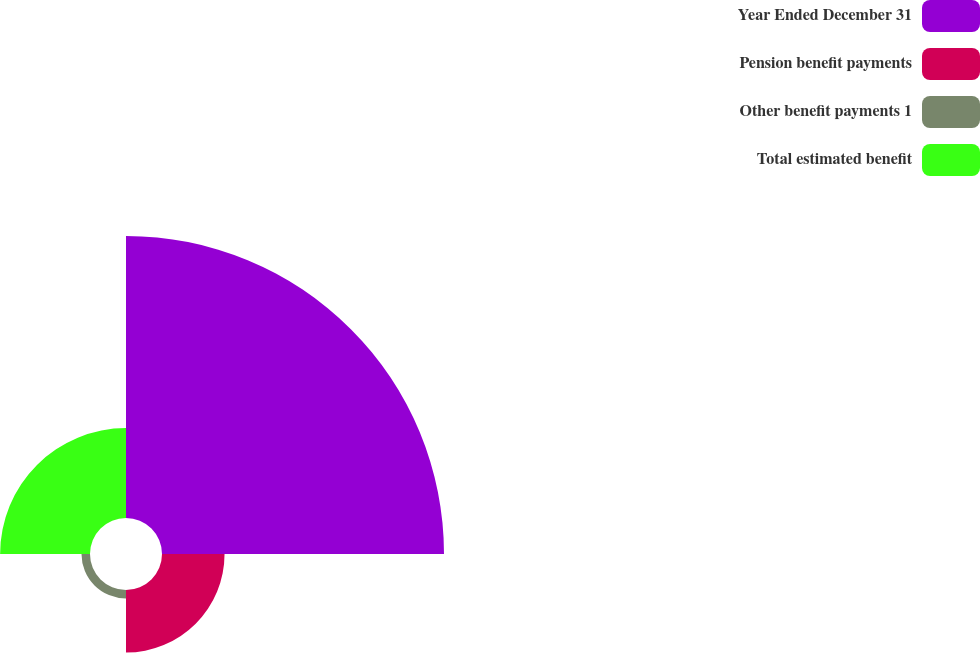Convert chart. <chart><loc_0><loc_0><loc_500><loc_500><pie_chart><fcel>Year Ended December 31<fcel>Pension benefit payments<fcel>Other benefit payments 1<fcel>Total estimated benefit<nl><fcel>63.66%<fcel>14.12%<fcel>1.92%<fcel>20.29%<nl></chart> 